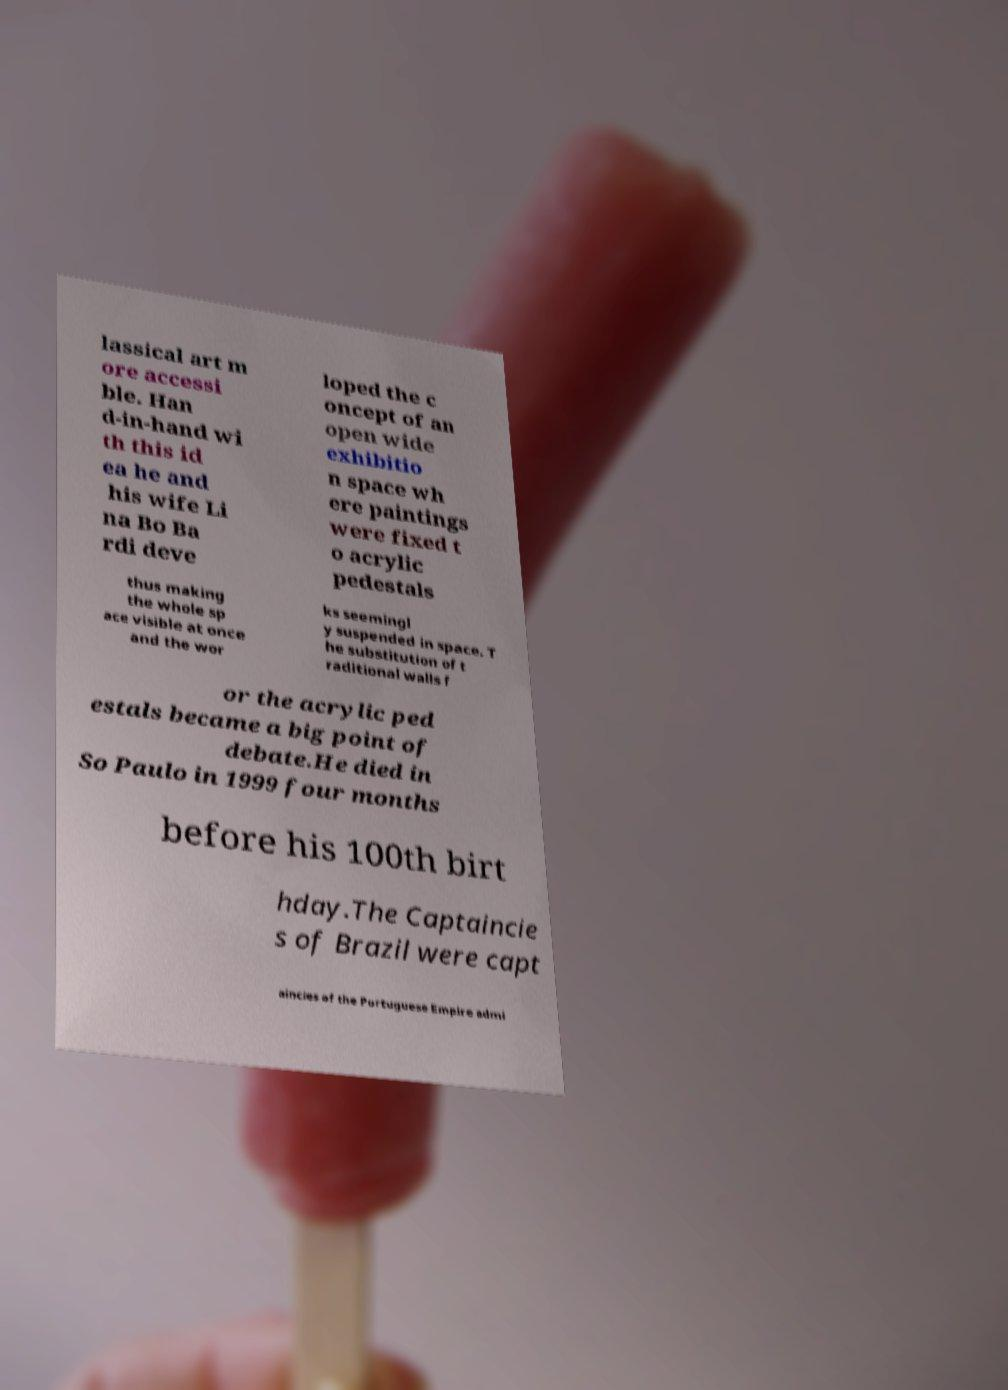Please identify and transcribe the text found in this image. lassical art m ore accessi ble. Han d-in-hand wi th this id ea he and his wife Li na Bo Ba rdi deve loped the c oncept of an open wide exhibitio n space wh ere paintings were fixed t o acrylic pedestals thus making the whole sp ace visible at once and the wor ks seemingl y suspended in space. T he substitution of t raditional walls f or the acrylic ped estals became a big point of debate.He died in So Paulo in 1999 four months before his 100th birt hday.The Captaincie s of Brazil were capt aincies of the Portuguese Empire admi 